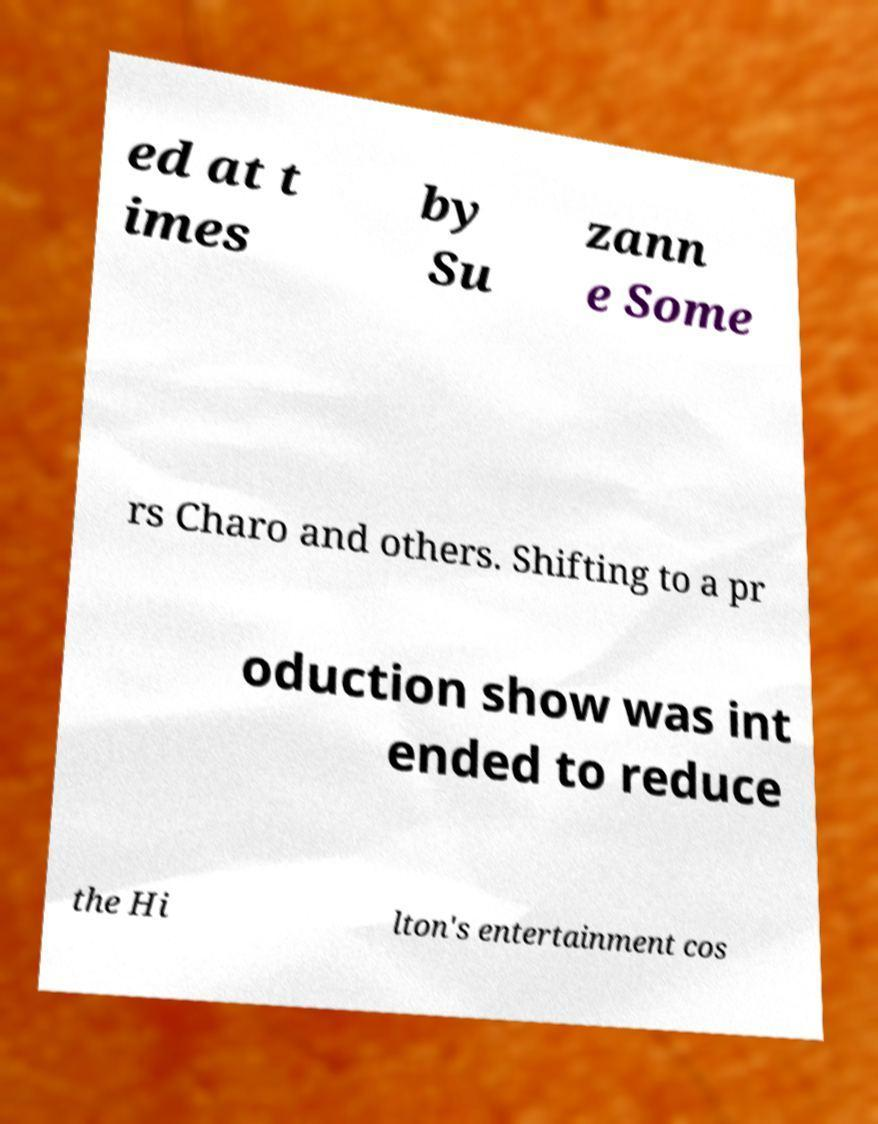Can you accurately transcribe the text from the provided image for me? ed at t imes by Su zann e Some rs Charo and others. Shifting to a pr oduction show was int ended to reduce the Hi lton's entertainment cos 